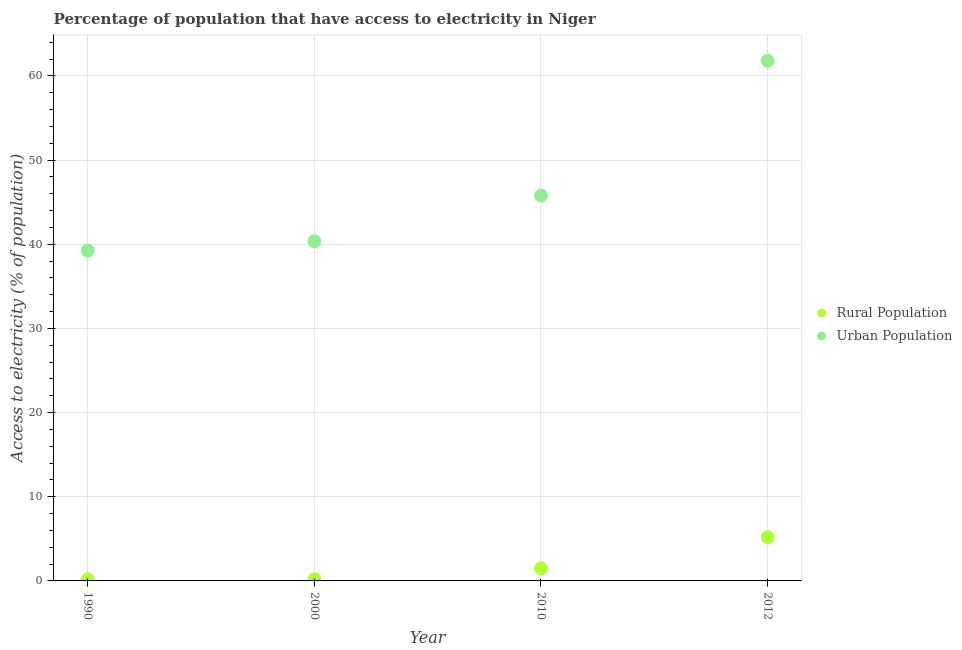Is the number of dotlines equal to the number of legend labels?
Make the answer very short. Yes. What is the percentage of rural population having access to electricity in 1990?
Ensure brevity in your answer.  0.2. Across all years, what is the maximum percentage of urban population having access to electricity?
Your answer should be compact. 61.8. In which year was the percentage of urban population having access to electricity minimum?
Make the answer very short. 1990. What is the total percentage of urban population having access to electricity in the graph?
Make the answer very short. 187.18. What is the difference between the percentage of urban population having access to electricity in 2000 and that in 2010?
Offer a terse response. -5.42. What is the difference between the percentage of urban population having access to electricity in 1990 and the percentage of rural population having access to electricity in 2000?
Provide a short and direct response. 39.04. What is the average percentage of urban population having access to electricity per year?
Provide a short and direct response. 46.79. In the year 1990, what is the difference between the percentage of rural population having access to electricity and percentage of urban population having access to electricity?
Offer a very short reply. -39.04. What is the ratio of the percentage of rural population having access to electricity in 1990 to that in 2010?
Your answer should be very brief. 0.13. Is the difference between the percentage of rural population having access to electricity in 1990 and 2000 greater than the difference between the percentage of urban population having access to electricity in 1990 and 2000?
Make the answer very short. Yes. What is the difference between the highest and the lowest percentage of urban population having access to electricity?
Your answer should be very brief. 22.56. In how many years, is the percentage of urban population having access to electricity greater than the average percentage of urban population having access to electricity taken over all years?
Ensure brevity in your answer.  1. Is the sum of the percentage of urban population having access to electricity in 2000 and 2010 greater than the maximum percentage of rural population having access to electricity across all years?
Keep it short and to the point. Yes. How many dotlines are there?
Provide a succinct answer. 2. What is the difference between two consecutive major ticks on the Y-axis?
Provide a succinct answer. 10. Does the graph contain any zero values?
Ensure brevity in your answer.  No. Where does the legend appear in the graph?
Provide a succinct answer. Center right. What is the title of the graph?
Provide a short and direct response. Percentage of population that have access to electricity in Niger. What is the label or title of the X-axis?
Provide a short and direct response. Year. What is the label or title of the Y-axis?
Your response must be concise. Access to electricity (% of population). What is the Access to electricity (% of population) in Rural Population in 1990?
Offer a terse response. 0.2. What is the Access to electricity (% of population) in Urban Population in 1990?
Keep it short and to the point. 39.24. What is the Access to electricity (% of population) of Rural Population in 2000?
Your answer should be very brief. 0.2. What is the Access to electricity (% of population) in Urban Population in 2000?
Offer a very short reply. 40.36. What is the Access to electricity (% of population) in Urban Population in 2010?
Ensure brevity in your answer.  45.78. What is the Access to electricity (% of population) of Rural Population in 2012?
Provide a short and direct response. 5.2. What is the Access to electricity (% of population) in Urban Population in 2012?
Ensure brevity in your answer.  61.8. Across all years, what is the maximum Access to electricity (% of population) in Urban Population?
Ensure brevity in your answer.  61.8. Across all years, what is the minimum Access to electricity (% of population) of Rural Population?
Give a very brief answer. 0.2. Across all years, what is the minimum Access to electricity (% of population) in Urban Population?
Your response must be concise. 39.24. What is the total Access to electricity (% of population) in Urban Population in the graph?
Ensure brevity in your answer.  187.18. What is the difference between the Access to electricity (% of population) of Rural Population in 1990 and that in 2000?
Keep it short and to the point. 0. What is the difference between the Access to electricity (% of population) in Urban Population in 1990 and that in 2000?
Your answer should be very brief. -1.12. What is the difference between the Access to electricity (% of population) of Rural Population in 1990 and that in 2010?
Your response must be concise. -1.3. What is the difference between the Access to electricity (% of population) in Urban Population in 1990 and that in 2010?
Your answer should be compact. -6.54. What is the difference between the Access to electricity (% of population) in Urban Population in 1990 and that in 2012?
Your answer should be compact. -22.56. What is the difference between the Access to electricity (% of population) in Rural Population in 2000 and that in 2010?
Give a very brief answer. -1.3. What is the difference between the Access to electricity (% of population) of Urban Population in 2000 and that in 2010?
Your answer should be very brief. -5.42. What is the difference between the Access to electricity (% of population) in Urban Population in 2000 and that in 2012?
Offer a terse response. -21.44. What is the difference between the Access to electricity (% of population) of Rural Population in 2010 and that in 2012?
Your answer should be compact. -3.7. What is the difference between the Access to electricity (% of population) of Urban Population in 2010 and that in 2012?
Offer a terse response. -16.02. What is the difference between the Access to electricity (% of population) of Rural Population in 1990 and the Access to electricity (% of population) of Urban Population in 2000?
Your answer should be compact. -40.16. What is the difference between the Access to electricity (% of population) in Rural Population in 1990 and the Access to electricity (% of population) in Urban Population in 2010?
Provide a succinct answer. -45.58. What is the difference between the Access to electricity (% of population) of Rural Population in 1990 and the Access to electricity (% of population) of Urban Population in 2012?
Your answer should be very brief. -61.6. What is the difference between the Access to electricity (% of population) of Rural Population in 2000 and the Access to electricity (% of population) of Urban Population in 2010?
Your answer should be compact. -45.58. What is the difference between the Access to electricity (% of population) of Rural Population in 2000 and the Access to electricity (% of population) of Urban Population in 2012?
Your answer should be very brief. -61.6. What is the difference between the Access to electricity (% of population) in Rural Population in 2010 and the Access to electricity (% of population) in Urban Population in 2012?
Keep it short and to the point. -60.3. What is the average Access to electricity (% of population) in Rural Population per year?
Your answer should be compact. 1.77. What is the average Access to electricity (% of population) of Urban Population per year?
Give a very brief answer. 46.79. In the year 1990, what is the difference between the Access to electricity (% of population) in Rural Population and Access to electricity (% of population) in Urban Population?
Offer a very short reply. -39.04. In the year 2000, what is the difference between the Access to electricity (% of population) of Rural Population and Access to electricity (% of population) of Urban Population?
Provide a succinct answer. -40.16. In the year 2010, what is the difference between the Access to electricity (% of population) in Rural Population and Access to electricity (% of population) in Urban Population?
Provide a short and direct response. -44.28. In the year 2012, what is the difference between the Access to electricity (% of population) in Rural Population and Access to electricity (% of population) in Urban Population?
Keep it short and to the point. -56.6. What is the ratio of the Access to electricity (% of population) of Urban Population in 1990 to that in 2000?
Ensure brevity in your answer.  0.97. What is the ratio of the Access to electricity (% of population) in Rural Population in 1990 to that in 2010?
Give a very brief answer. 0.13. What is the ratio of the Access to electricity (% of population) of Urban Population in 1990 to that in 2010?
Offer a very short reply. 0.86. What is the ratio of the Access to electricity (% of population) of Rural Population in 1990 to that in 2012?
Make the answer very short. 0.04. What is the ratio of the Access to electricity (% of population) in Urban Population in 1990 to that in 2012?
Your response must be concise. 0.64. What is the ratio of the Access to electricity (% of population) in Rural Population in 2000 to that in 2010?
Ensure brevity in your answer.  0.13. What is the ratio of the Access to electricity (% of population) in Urban Population in 2000 to that in 2010?
Provide a succinct answer. 0.88. What is the ratio of the Access to electricity (% of population) of Rural Population in 2000 to that in 2012?
Give a very brief answer. 0.04. What is the ratio of the Access to electricity (% of population) in Urban Population in 2000 to that in 2012?
Your response must be concise. 0.65. What is the ratio of the Access to electricity (% of population) of Rural Population in 2010 to that in 2012?
Your response must be concise. 0.29. What is the ratio of the Access to electricity (% of population) in Urban Population in 2010 to that in 2012?
Give a very brief answer. 0.74. What is the difference between the highest and the second highest Access to electricity (% of population) of Urban Population?
Make the answer very short. 16.02. What is the difference between the highest and the lowest Access to electricity (% of population) of Urban Population?
Keep it short and to the point. 22.56. 